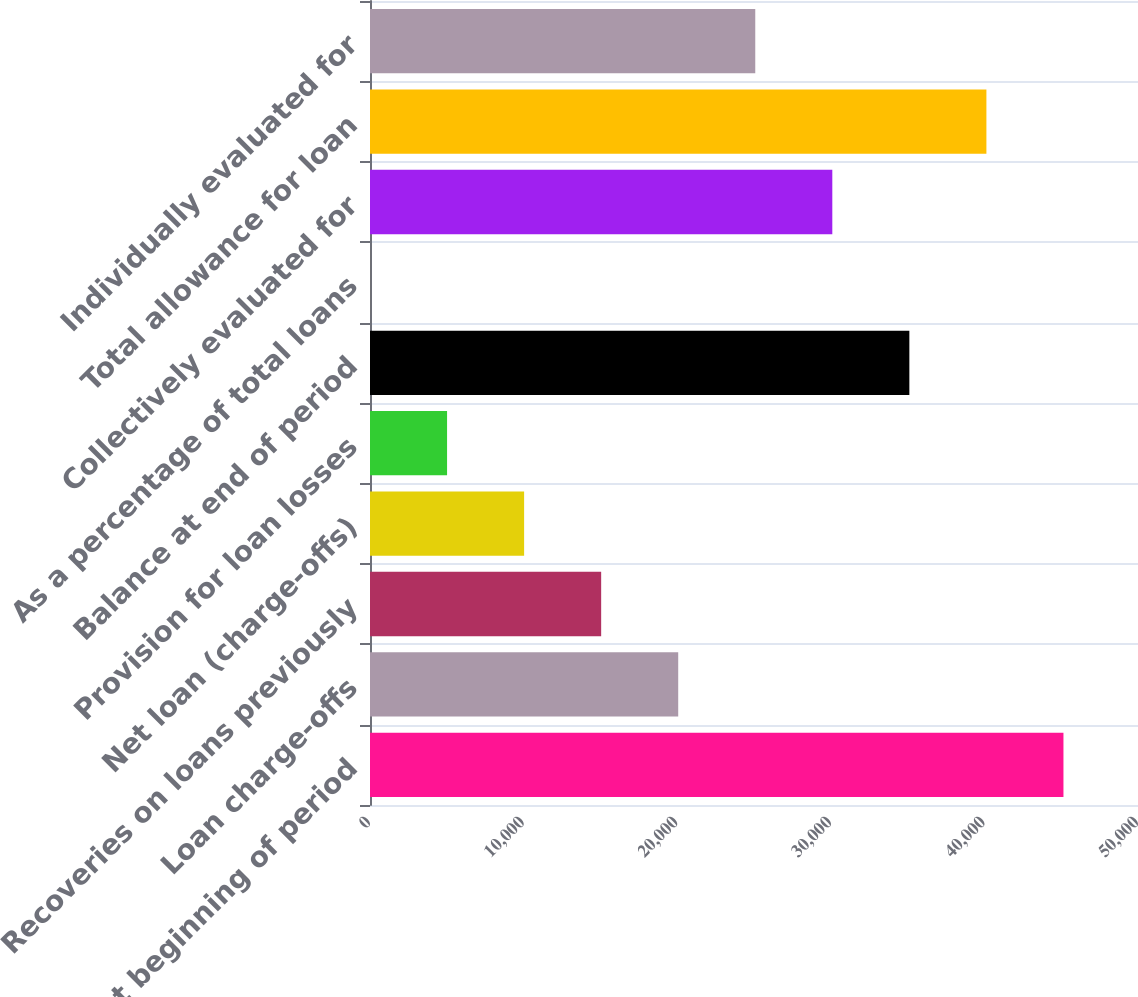<chart> <loc_0><loc_0><loc_500><loc_500><bar_chart><fcel>Balance at beginning of period<fcel>Loan charge-offs<fcel>Recoveries on loans previously<fcel>Net loan (charge-offs)<fcel>Provision for loan losses<fcel>Balance at end of period<fcel>As a percentage of total loans<fcel>Collectively evaluated for<fcel>Total allowance for loan<fcel>Individually evaluated for<nl><fcel>45146.9<fcel>20066<fcel>15049.9<fcel>10033.7<fcel>5017.51<fcel>35114.5<fcel>1.34<fcel>30098.4<fcel>40130.7<fcel>25082.2<nl></chart> 